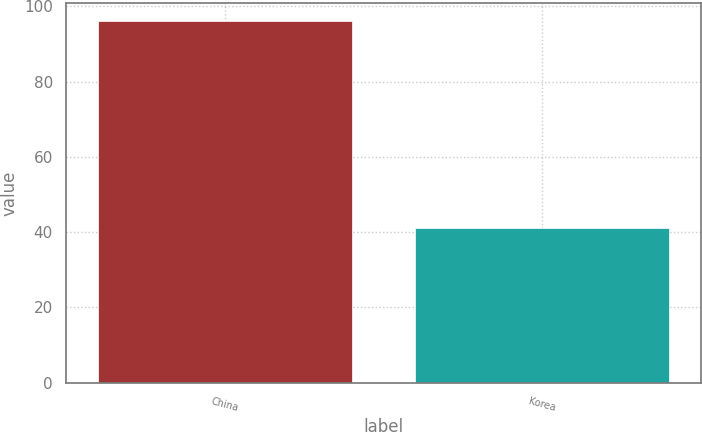Convert chart. <chart><loc_0><loc_0><loc_500><loc_500><bar_chart><fcel>China<fcel>Korea<nl><fcel>96<fcel>41<nl></chart> 